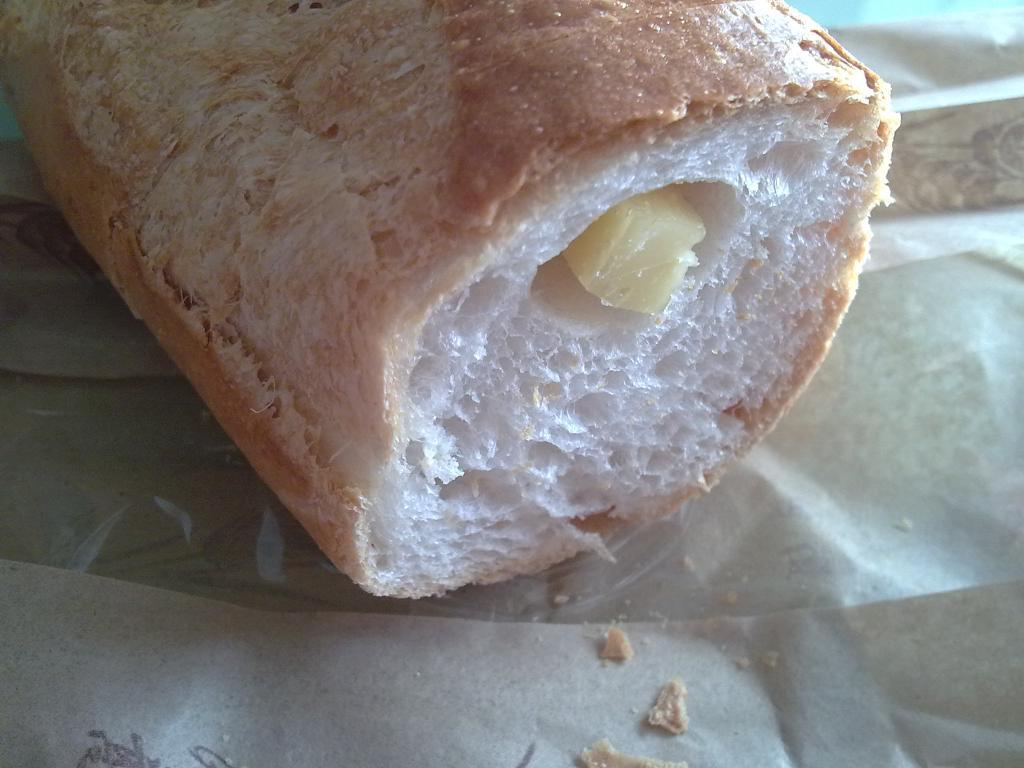What is the main subject of the image? There is a food item in the image. How is the food item packaged or presented? The food item is on a wrapper. Where is the food item located in the image? The food item is located in the middle of the image. What sense is the food item appealing to in the image? The image does not convey any sensory information about the food item, so it cannot be determined which sense it is appealing to. 